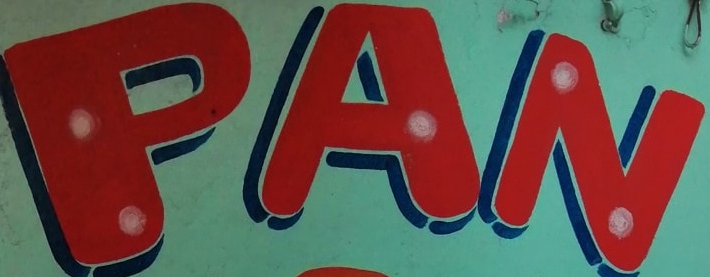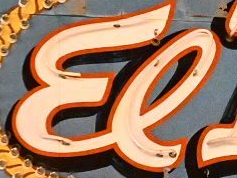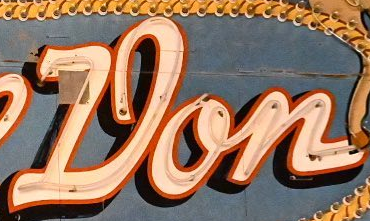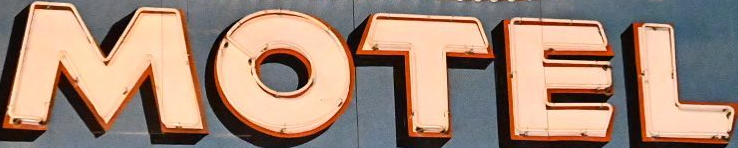Read the text from these images in sequence, separated by a semicolon. PAN; El; Don; MOTEL 